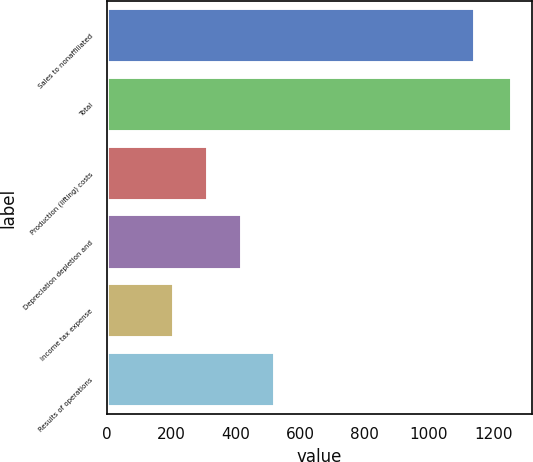Convert chart. <chart><loc_0><loc_0><loc_500><loc_500><bar_chart><fcel>Sales to nonaffiliated<fcel>Total<fcel>Production (lifting) costs<fcel>Depreciation depletion and<fcel>Income tax expense<fcel>Results of operations<nl><fcel>1144<fcel>1258<fcel>313<fcel>418<fcel>208<fcel>523<nl></chart> 